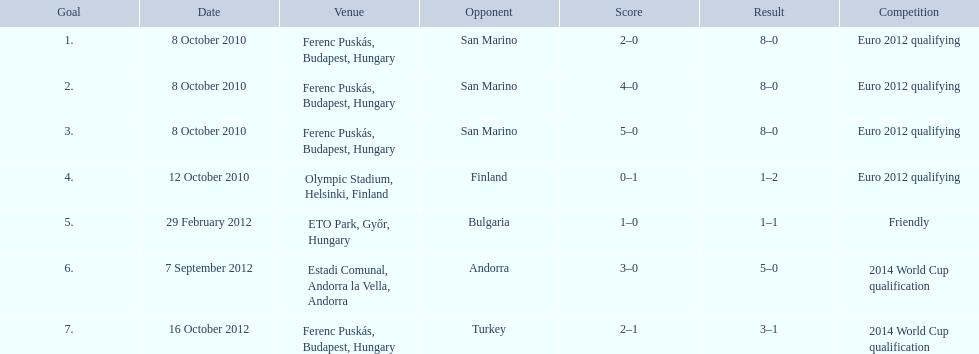How many goals were netted in the euro 2012 qualifying contest? 12. 